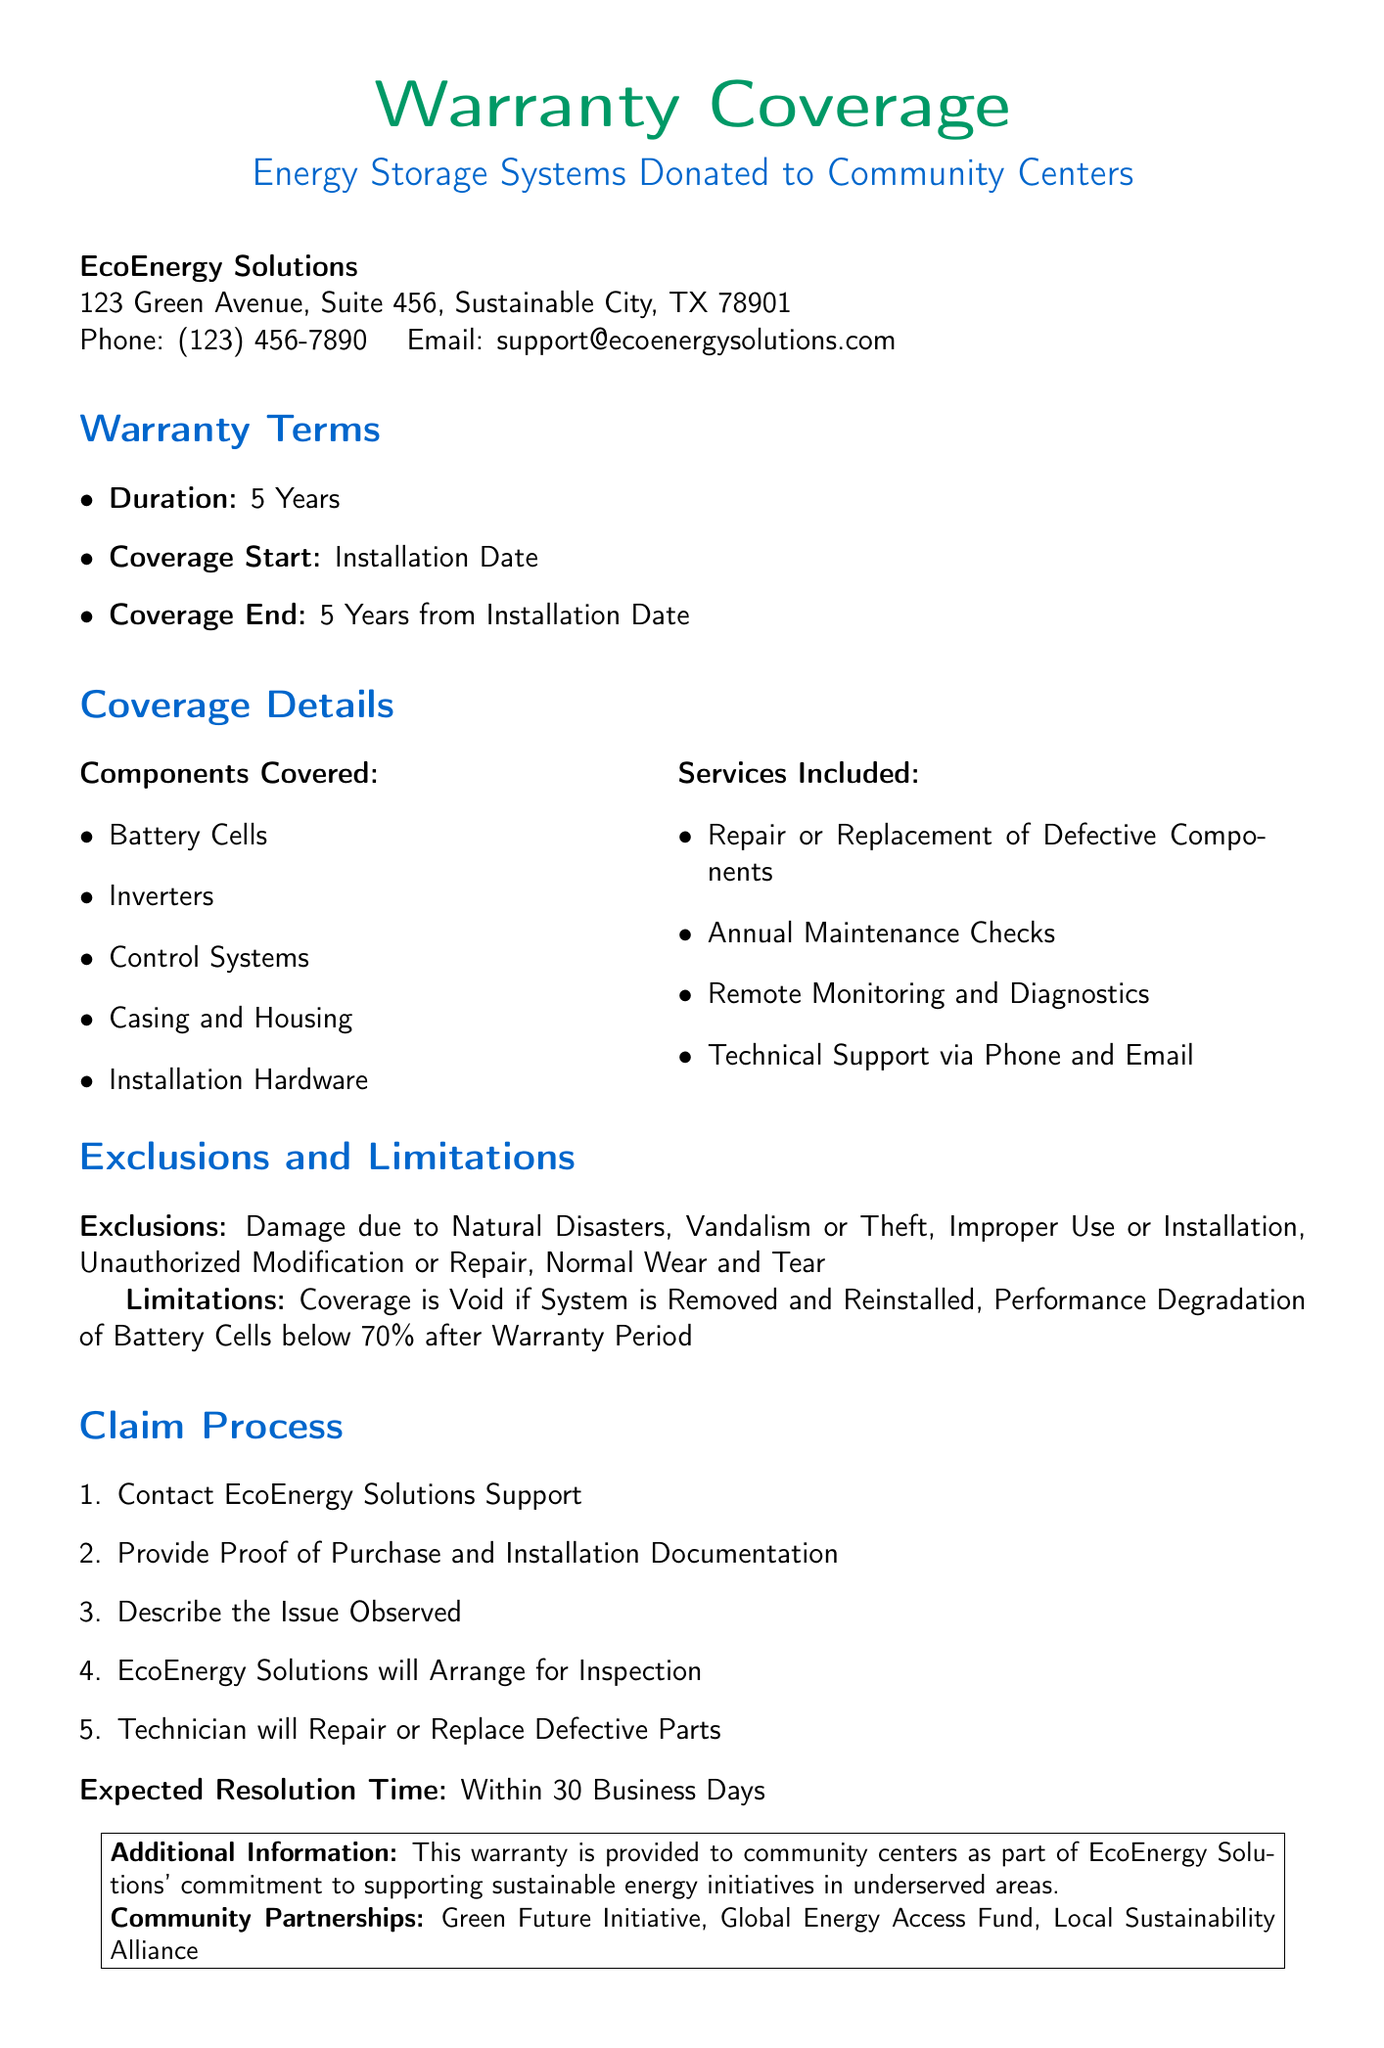What is the duration of the warranty? The warranty duration is specifically stated in the document as 5 Years.
Answer: 5 Years What components are covered under the warranty? The document lists the components covered under the warranty, which include Battery Cells, Inverters, Control Systems, Casing and Housing, and Installation Hardware.
Answer: Battery Cells, Inverters, Control Systems, Casing and Housing, Installation Hardware What is the expected resolution time for claims? The expected resolution time for claims is mentioned in the document as within 30 Business Days.
Answer: Within 30 Business Days What must be provided to initiate a claim? According to the document, one must provide Proof of Purchase and Installation Documentation to initiate a claim.
Answer: Proof of Purchase and Installation Documentation Which types of damage are excluded from the warranty? The document specifies that certain damages such as Natural Disasters, Vandalism or Theft, Improper Use or Installation, Unauthorized Modification or Repair, and Normal Wear and Tear are excluded.
Answer: Natural Disasters, Vandalism or Theft, Improper Use or Installation, Unauthorized Modification or Repair, Normal Wear and Tear What is the coverage start date? The coverage start date is clearly defined in the document as the Installation Date.
Answer: Installation Date Is technical support included in the warranty services? The document mentions Technical Support via Phone and Email as part of the services included, confirming that it is offered.
Answer: Yes What happens if the system is removed and reinstalled? The document states that the coverage is void if the system is removed and reinstalled.
Answer: Coverage is Void Who can be contacted for support related to the warranty? The support contact information is provided in the document, indicating that EcoEnergy Solutions Support should be contacted.
Answer: EcoEnergy Solutions Support 